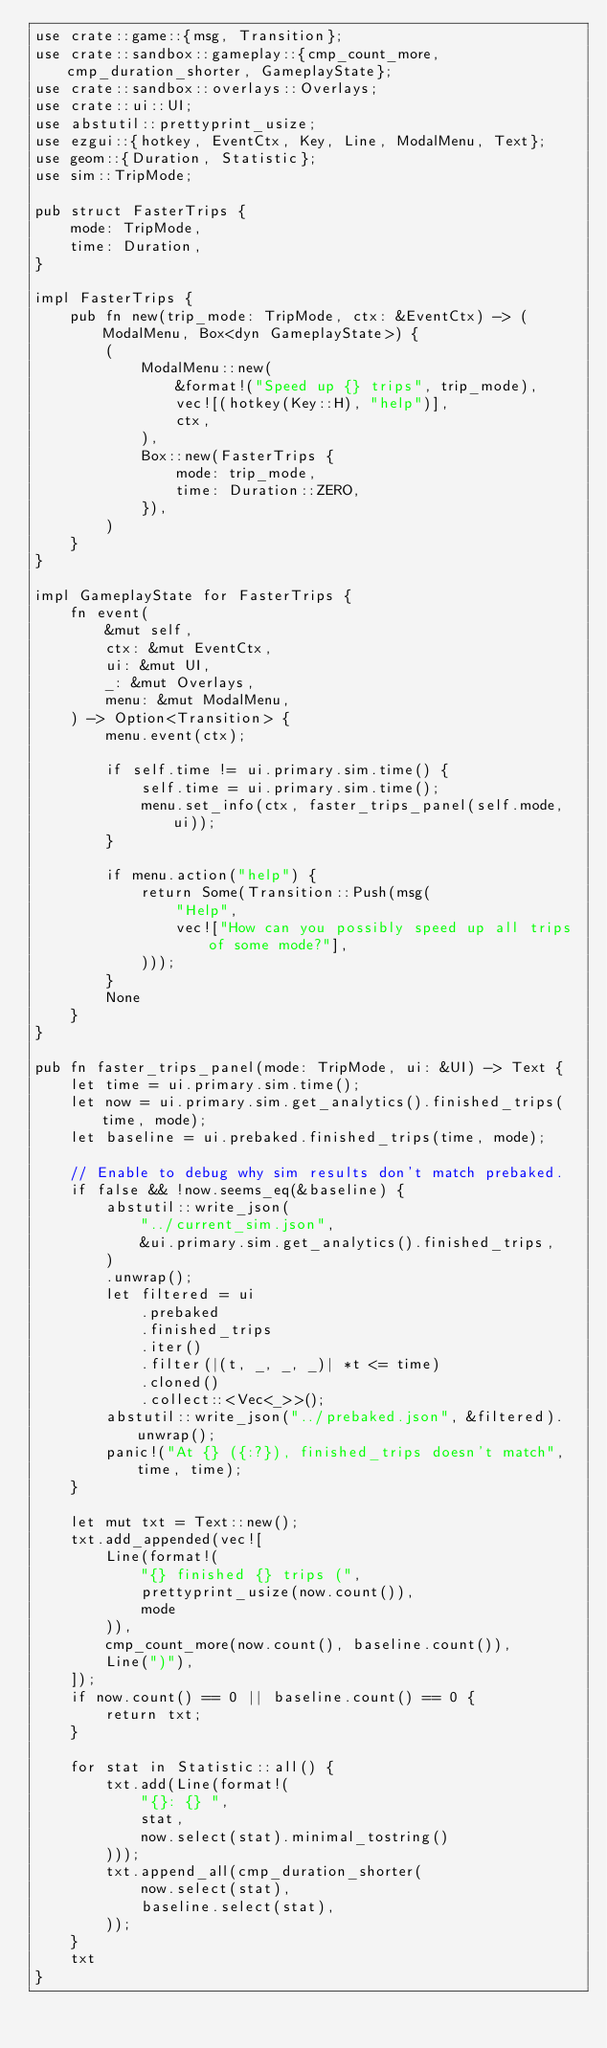Convert code to text. <code><loc_0><loc_0><loc_500><loc_500><_Rust_>use crate::game::{msg, Transition};
use crate::sandbox::gameplay::{cmp_count_more, cmp_duration_shorter, GameplayState};
use crate::sandbox::overlays::Overlays;
use crate::ui::UI;
use abstutil::prettyprint_usize;
use ezgui::{hotkey, EventCtx, Key, Line, ModalMenu, Text};
use geom::{Duration, Statistic};
use sim::TripMode;

pub struct FasterTrips {
    mode: TripMode,
    time: Duration,
}

impl FasterTrips {
    pub fn new(trip_mode: TripMode, ctx: &EventCtx) -> (ModalMenu, Box<dyn GameplayState>) {
        (
            ModalMenu::new(
                &format!("Speed up {} trips", trip_mode),
                vec![(hotkey(Key::H), "help")],
                ctx,
            ),
            Box::new(FasterTrips {
                mode: trip_mode,
                time: Duration::ZERO,
            }),
        )
    }
}

impl GameplayState for FasterTrips {
    fn event(
        &mut self,
        ctx: &mut EventCtx,
        ui: &mut UI,
        _: &mut Overlays,
        menu: &mut ModalMenu,
    ) -> Option<Transition> {
        menu.event(ctx);

        if self.time != ui.primary.sim.time() {
            self.time = ui.primary.sim.time();
            menu.set_info(ctx, faster_trips_panel(self.mode, ui));
        }

        if menu.action("help") {
            return Some(Transition::Push(msg(
                "Help",
                vec!["How can you possibly speed up all trips of some mode?"],
            )));
        }
        None
    }
}

pub fn faster_trips_panel(mode: TripMode, ui: &UI) -> Text {
    let time = ui.primary.sim.time();
    let now = ui.primary.sim.get_analytics().finished_trips(time, mode);
    let baseline = ui.prebaked.finished_trips(time, mode);

    // Enable to debug why sim results don't match prebaked.
    if false && !now.seems_eq(&baseline) {
        abstutil::write_json(
            "../current_sim.json",
            &ui.primary.sim.get_analytics().finished_trips,
        )
        .unwrap();
        let filtered = ui
            .prebaked
            .finished_trips
            .iter()
            .filter(|(t, _, _, _)| *t <= time)
            .cloned()
            .collect::<Vec<_>>();
        abstutil::write_json("../prebaked.json", &filtered).unwrap();
        panic!("At {} ({:?}), finished_trips doesn't match", time, time);
    }

    let mut txt = Text::new();
    txt.add_appended(vec![
        Line(format!(
            "{} finished {} trips (",
            prettyprint_usize(now.count()),
            mode
        )),
        cmp_count_more(now.count(), baseline.count()),
        Line(")"),
    ]);
    if now.count() == 0 || baseline.count() == 0 {
        return txt;
    }

    for stat in Statistic::all() {
        txt.add(Line(format!(
            "{}: {} ",
            stat,
            now.select(stat).minimal_tostring()
        )));
        txt.append_all(cmp_duration_shorter(
            now.select(stat),
            baseline.select(stat),
        ));
    }
    txt
}
</code> 